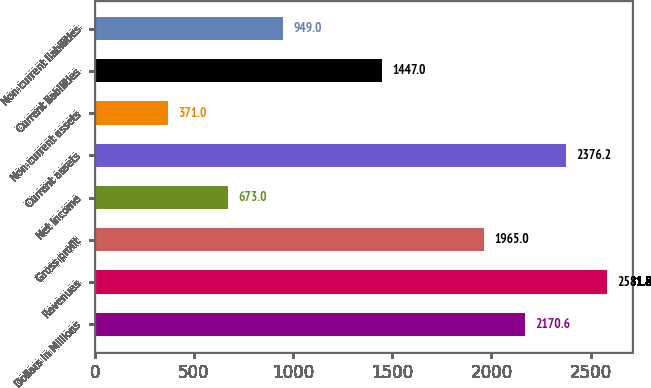<chart> <loc_0><loc_0><loc_500><loc_500><bar_chart><fcel>Dollars in Millions<fcel>Revenues<fcel>Gross profit<fcel>Net income<fcel>Current assets<fcel>Non-current assets<fcel>Current liabilities<fcel>Non-current liabilities<nl><fcel>2170.6<fcel>2581.8<fcel>1965<fcel>673<fcel>2376.2<fcel>371<fcel>1447<fcel>949<nl></chart> 